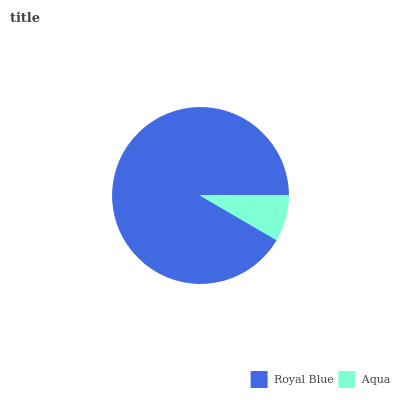Is Aqua the minimum?
Answer yes or no. Yes. Is Royal Blue the maximum?
Answer yes or no. Yes. Is Aqua the maximum?
Answer yes or no. No. Is Royal Blue greater than Aqua?
Answer yes or no. Yes. Is Aqua less than Royal Blue?
Answer yes or no. Yes. Is Aqua greater than Royal Blue?
Answer yes or no. No. Is Royal Blue less than Aqua?
Answer yes or no. No. Is Royal Blue the high median?
Answer yes or no. Yes. Is Aqua the low median?
Answer yes or no. Yes. Is Aqua the high median?
Answer yes or no. No. Is Royal Blue the low median?
Answer yes or no. No. 